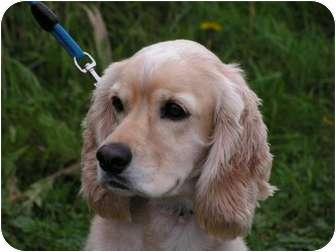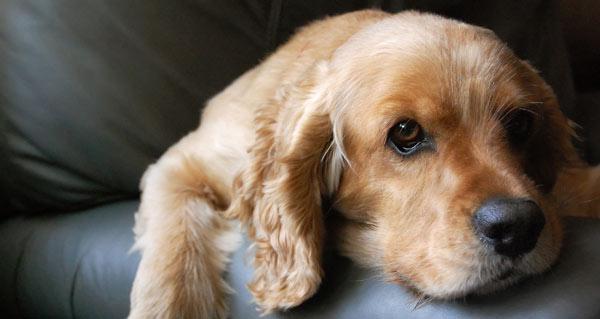The first image is the image on the left, the second image is the image on the right. For the images shown, is this caption "The dog in the image on the left is outside." true? Answer yes or no. Yes. The first image is the image on the left, the second image is the image on the right. Assess this claim about the two images: "One image shows a blonde spaniel with a metal tag on its collar and its head cocked to the left.". Correct or not? Answer yes or no. No. 